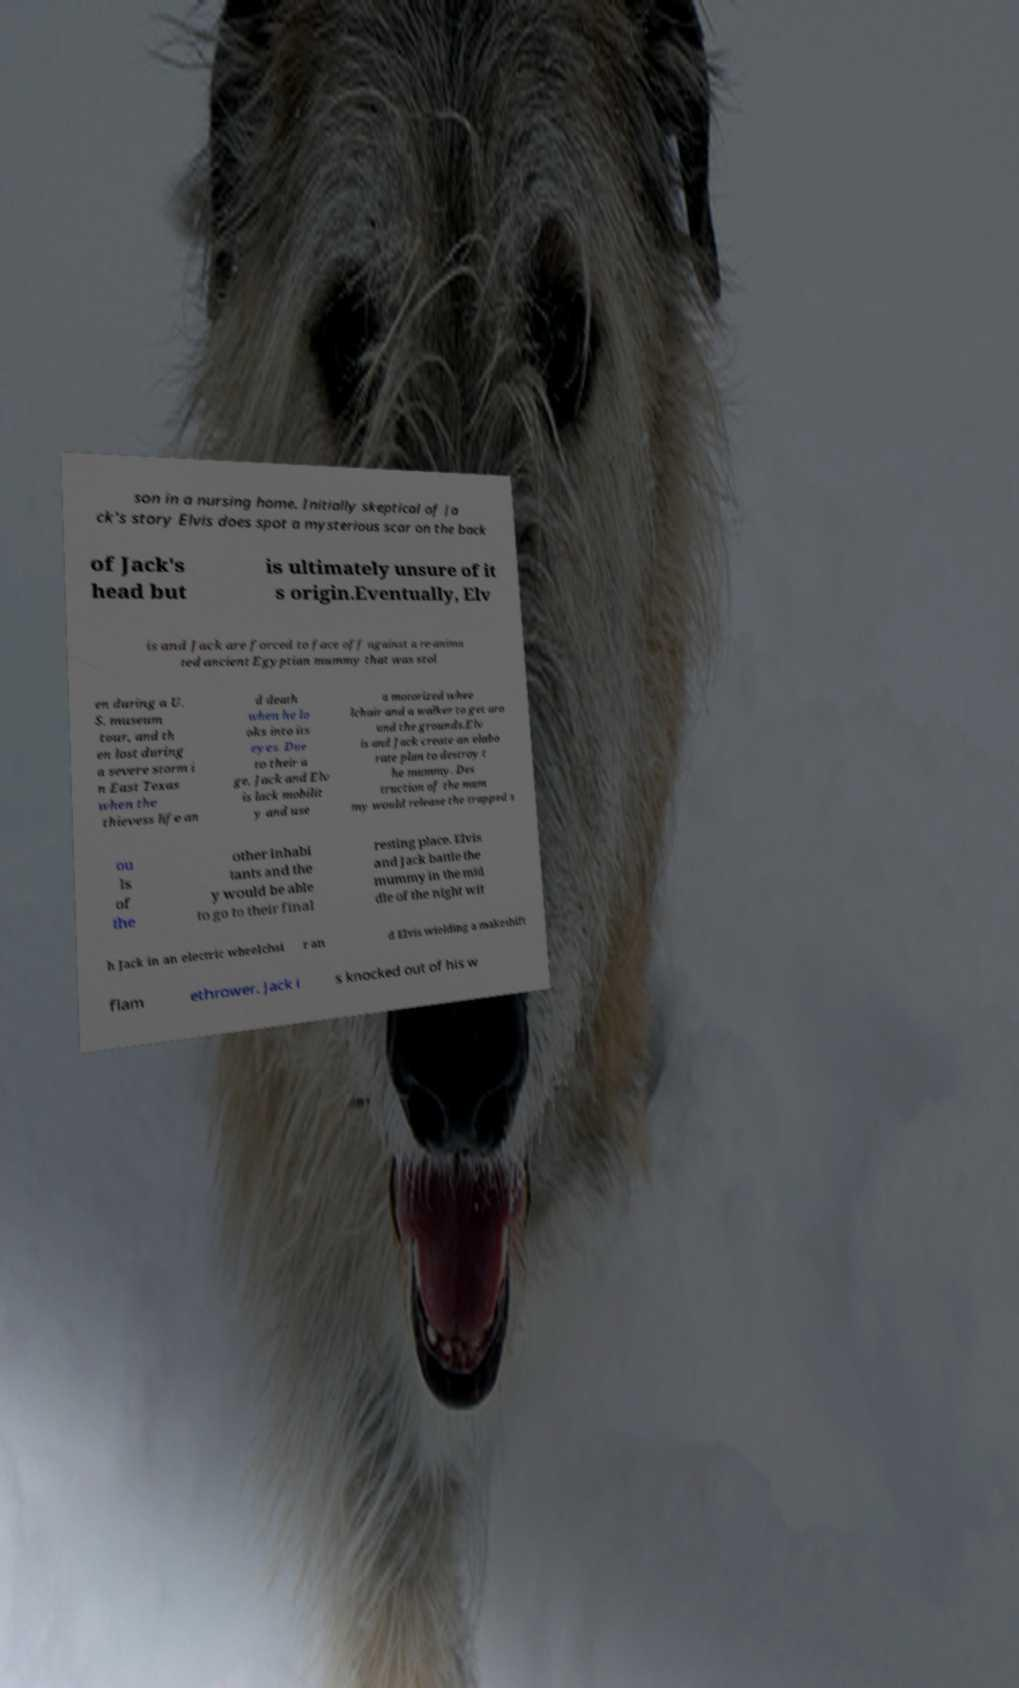I need the written content from this picture converted into text. Can you do that? son in a nursing home. Initially skeptical of Ja ck's story Elvis does spot a mysterious scar on the back of Jack's head but is ultimately unsure of it s origin.Eventually, Elv is and Jack are forced to face off against a re-anima ted ancient Egyptian mummy that was stol en during a U. S. museum tour, and th en lost during a severe storm i n East Texas when the thievess life an d death when he lo oks into its eyes. Due to their a ge, Jack and Elv is lack mobilit y and use a motorized whee lchair and a walker to get aro und the grounds.Elv is and Jack create an elabo rate plan to destroy t he mummy. Des truction of the mum my would release the trapped s ou ls of the other inhabi tants and the y would be able to go to their final resting place. Elvis and Jack battle the mummy in the mid dle of the night wit h Jack in an electric wheelchai r an d Elvis wielding a makeshift flam ethrower. Jack i s knocked out of his w 